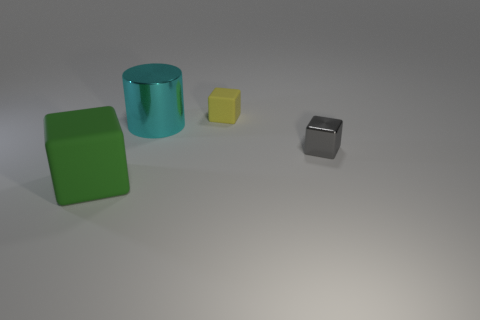What is the relationship between the sizes of the objects? The sizes of the objects seem to be in descending order from left to right. The green cube is the largest, followed by the cyan cylinder, which is a bit shorter. The yellow cube is smaller than both, and the gray cube is the smallest in the group, suggesting a deliberate scaling of the objects. 